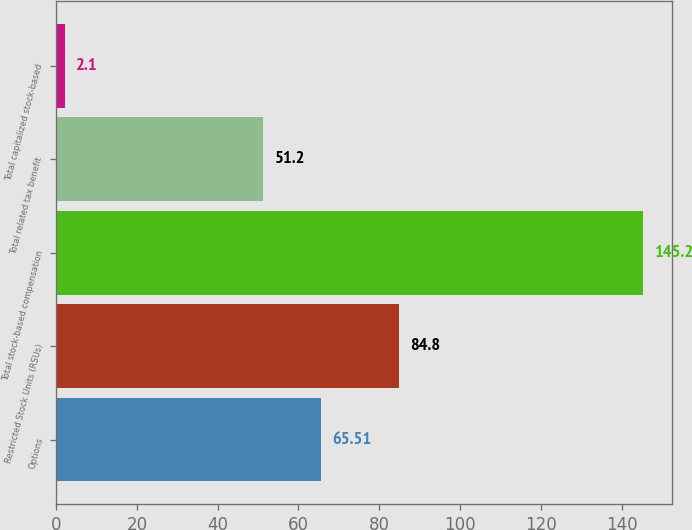<chart> <loc_0><loc_0><loc_500><loc_500><bar_chart><fcel>Options<fcel>Restricted Stock Units (RSUs)<fcel>Total stock-based compensation<fcel>Total related tax benefit<fcel>Total capitalized stock-based<nl><fcel>65.51<fcel>84.8<fcel>145.2<fcel>51.2<fcel>2.1<nl></chart> 